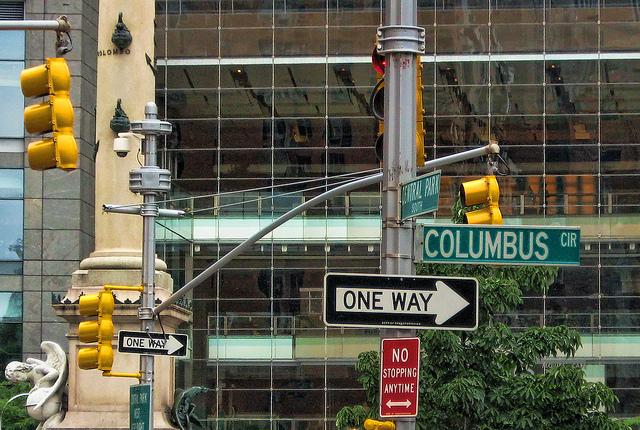Who are the street signs for? Please explain your reasoning. drivers. There are one way and no stopping anytime signs. pedestrians are not affected by these signs. 